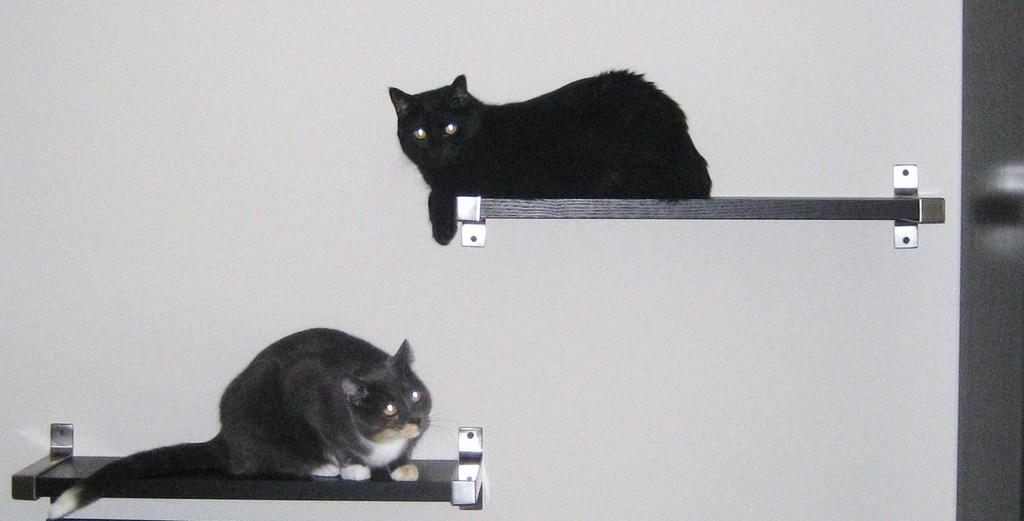What objects are present in the image? There are two boards and two cats in the image. Can you describe the position of the cats? The cats are on the boards in the image. What can be seen in the background of the image? There is a wall in the background of the image. Is there any indication of an entrance or exit in the image? There might be a door on the right side of the image. What type of straw is being used by the servant in the image? There is no servant or straw present in the image. What is the toothbrush made of in the image? There is no toothbrush present in the image. 